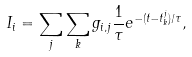<formula> <loc_0><loc_0><loc_500><loc_500>I _ { i } = \sum _ { j } \sum _ { k } g _ { i , j } \frac { 1 } { \tau } e ^ { - ( t - t _ { k } ^ { j } ) / \tau } ,</formula> 